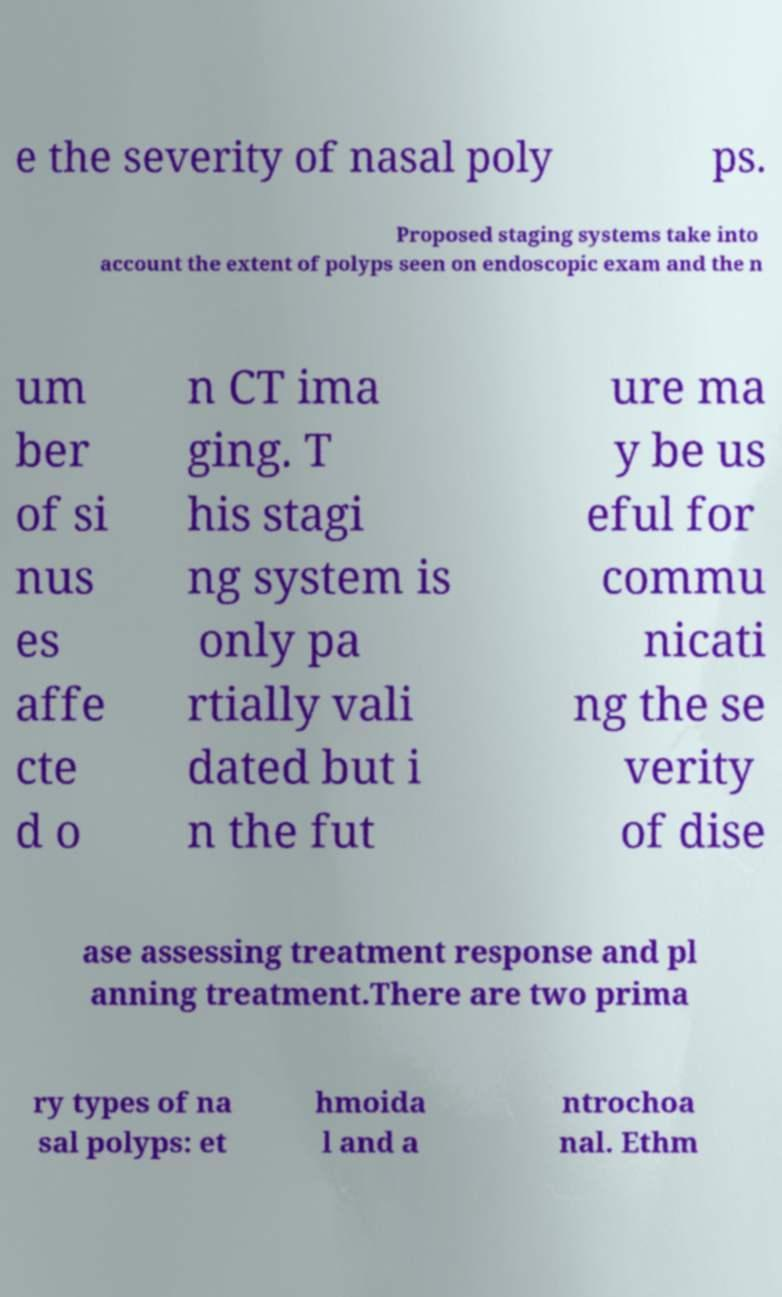Could you assist in decoding the text presented in this image and type it out clearly? e the severity of nasal poly ps. Proposed staging systems take into account the extent of polyps seen on endoscopic exam and the n um ber of si nus es affe cte d o n CT ima ging. T his stagi ng system is only pa rtially vali dated but i n the fut ure ma y be us eful for commu nicati ng the se verity of dise ase assessing treatment response and pl anning treatment.There are two prima ry types of na sal polyps: et hmoida l and a ntrochoa nal. Ethm 